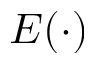Convert formula to latex. <formula><loc_0><loc_0><loc_500><loc_500>E ( \cdot )</formula> 